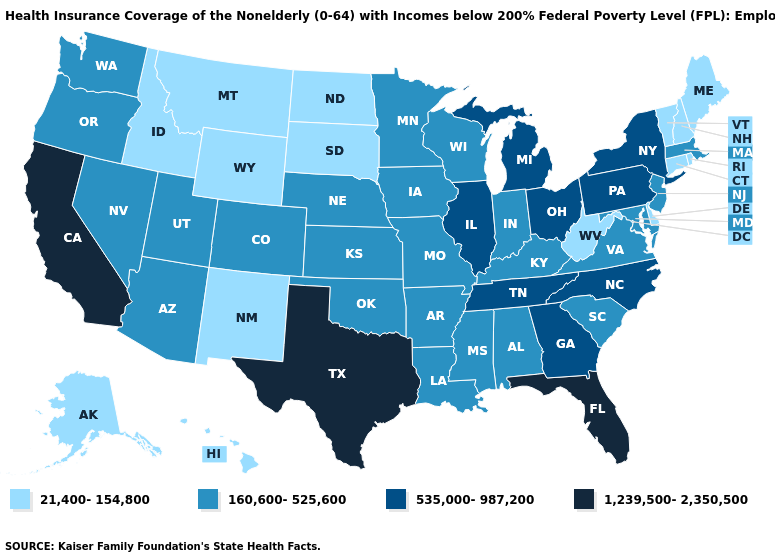Does North Dakota have the highest value in the USA?
Keep it brief. No. Name the states that have a value in the range 535,000-987,200?
Answer briefly. Georgia, Illinois, Michigan, New York, North Carolina, Ohio, Pennsylvania, Tennessee. Among the states that border Kansas , which have the highest value?
Give a very brief answer. Colorado, Missouri, Nebraska, Oklahoma. Name the states that have a value in the range 21,400-154,800?
Short answer required. Alaska, Connecticut, Delaware, Hawaii, Idaho, Maine, Montana, New Hampshire, New Mexico, North Dakota, Rhode Island, South Dakota, Vermont, West Virginia, Wyoming. Name the states that have a value in the range 1,239,500-2,350,500?
Answer briefly. California, Florida, Texas. Does Pennsylvania have the lowest value in the Northeast?
Short answer required. No. What is the value of North Dakota?
Short answer required. 21,400-154,800. Does California have the highest value in the USA?
Short answer required. Yes. Name the states that have a value in the range 535,000-987,200?
Keep it brief. Georgia, Illinois, Michigan, New York, North Carolina, Ohio, Pennsylvania, Tennessee. What is the lowest value in the USA?
Short answer required. 21,400-154,800. What is the value of California?
Be succinct. 1,239,500-2,350,500. What is the lowest value in states that border Iowa?
Concise answer only. 21,400-154,800. What is the highest value in the Northeast ?
Write a very short answer. 535,000-987,200. Does Colorado have a higher value than Minnesota?
Be succinct. No. What is the value of Utah?
Short answer required. 160,600-525,600. 